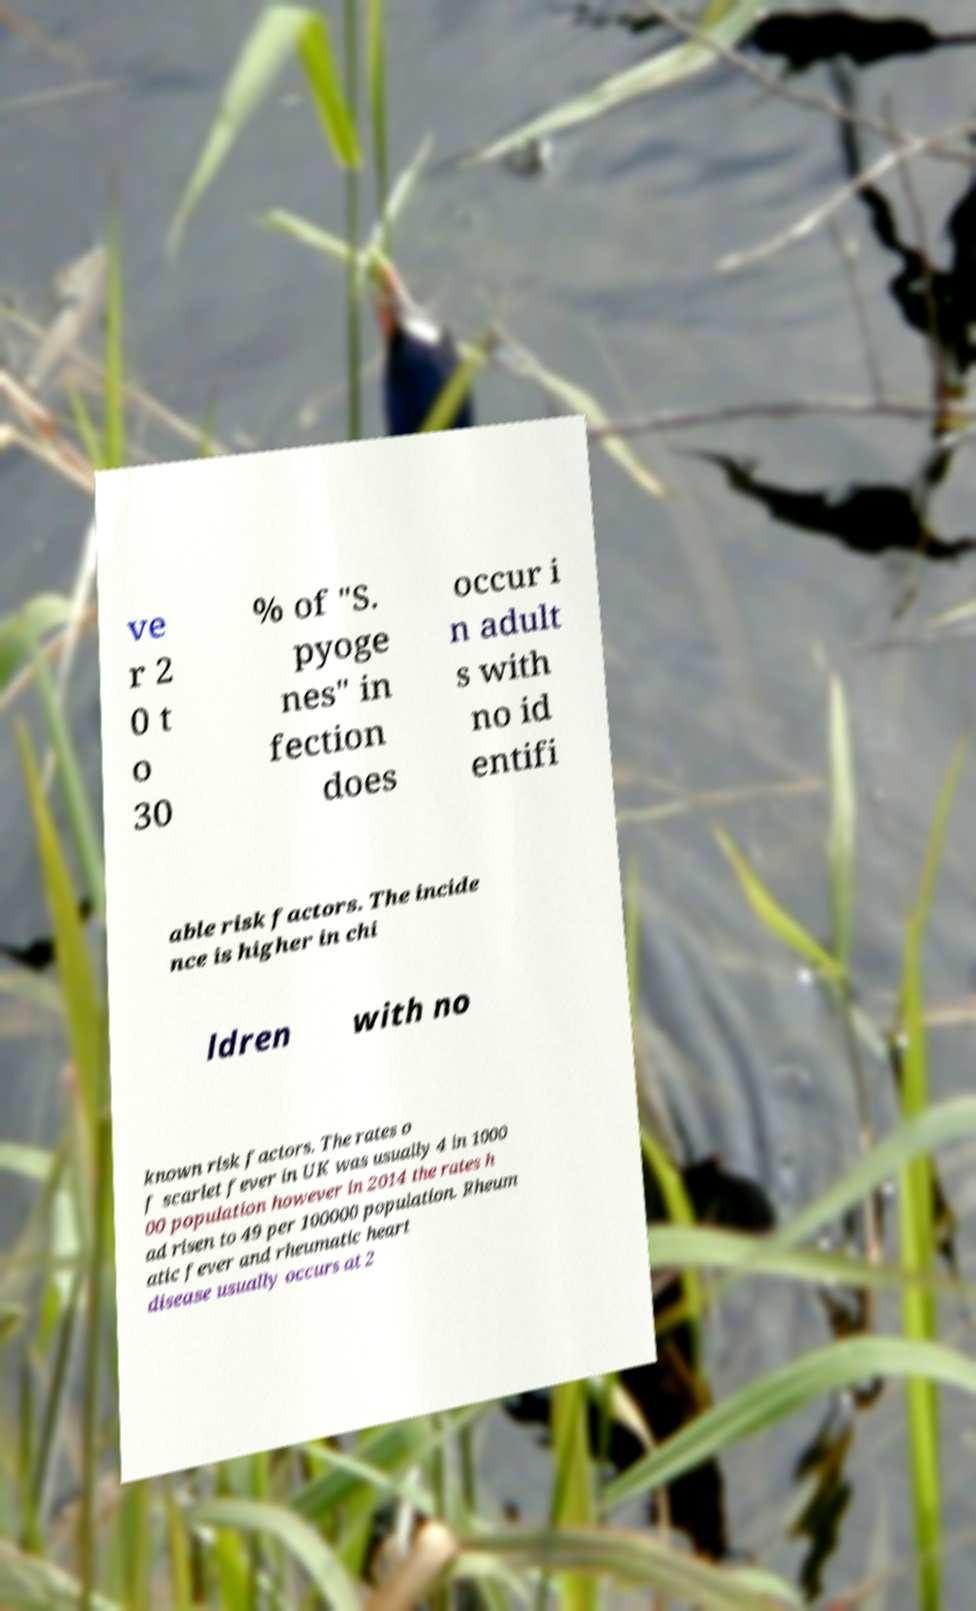Can you accurately transcribe the text from the provided image for me? ve r 2 0 t o 30 % of "S. pyoge nes" in fection does occur i n adult s with no id entifi able risk factors. The incide nce is higher in chi ldren with no known risk factors. The rates o f scarlet fever in UK was usually 4 in 1000 00 population however in 2014 the rates h ad risen to 49 per 100000 population. Rheum atic fever and rheumatic heart disease usually occurs at 2 